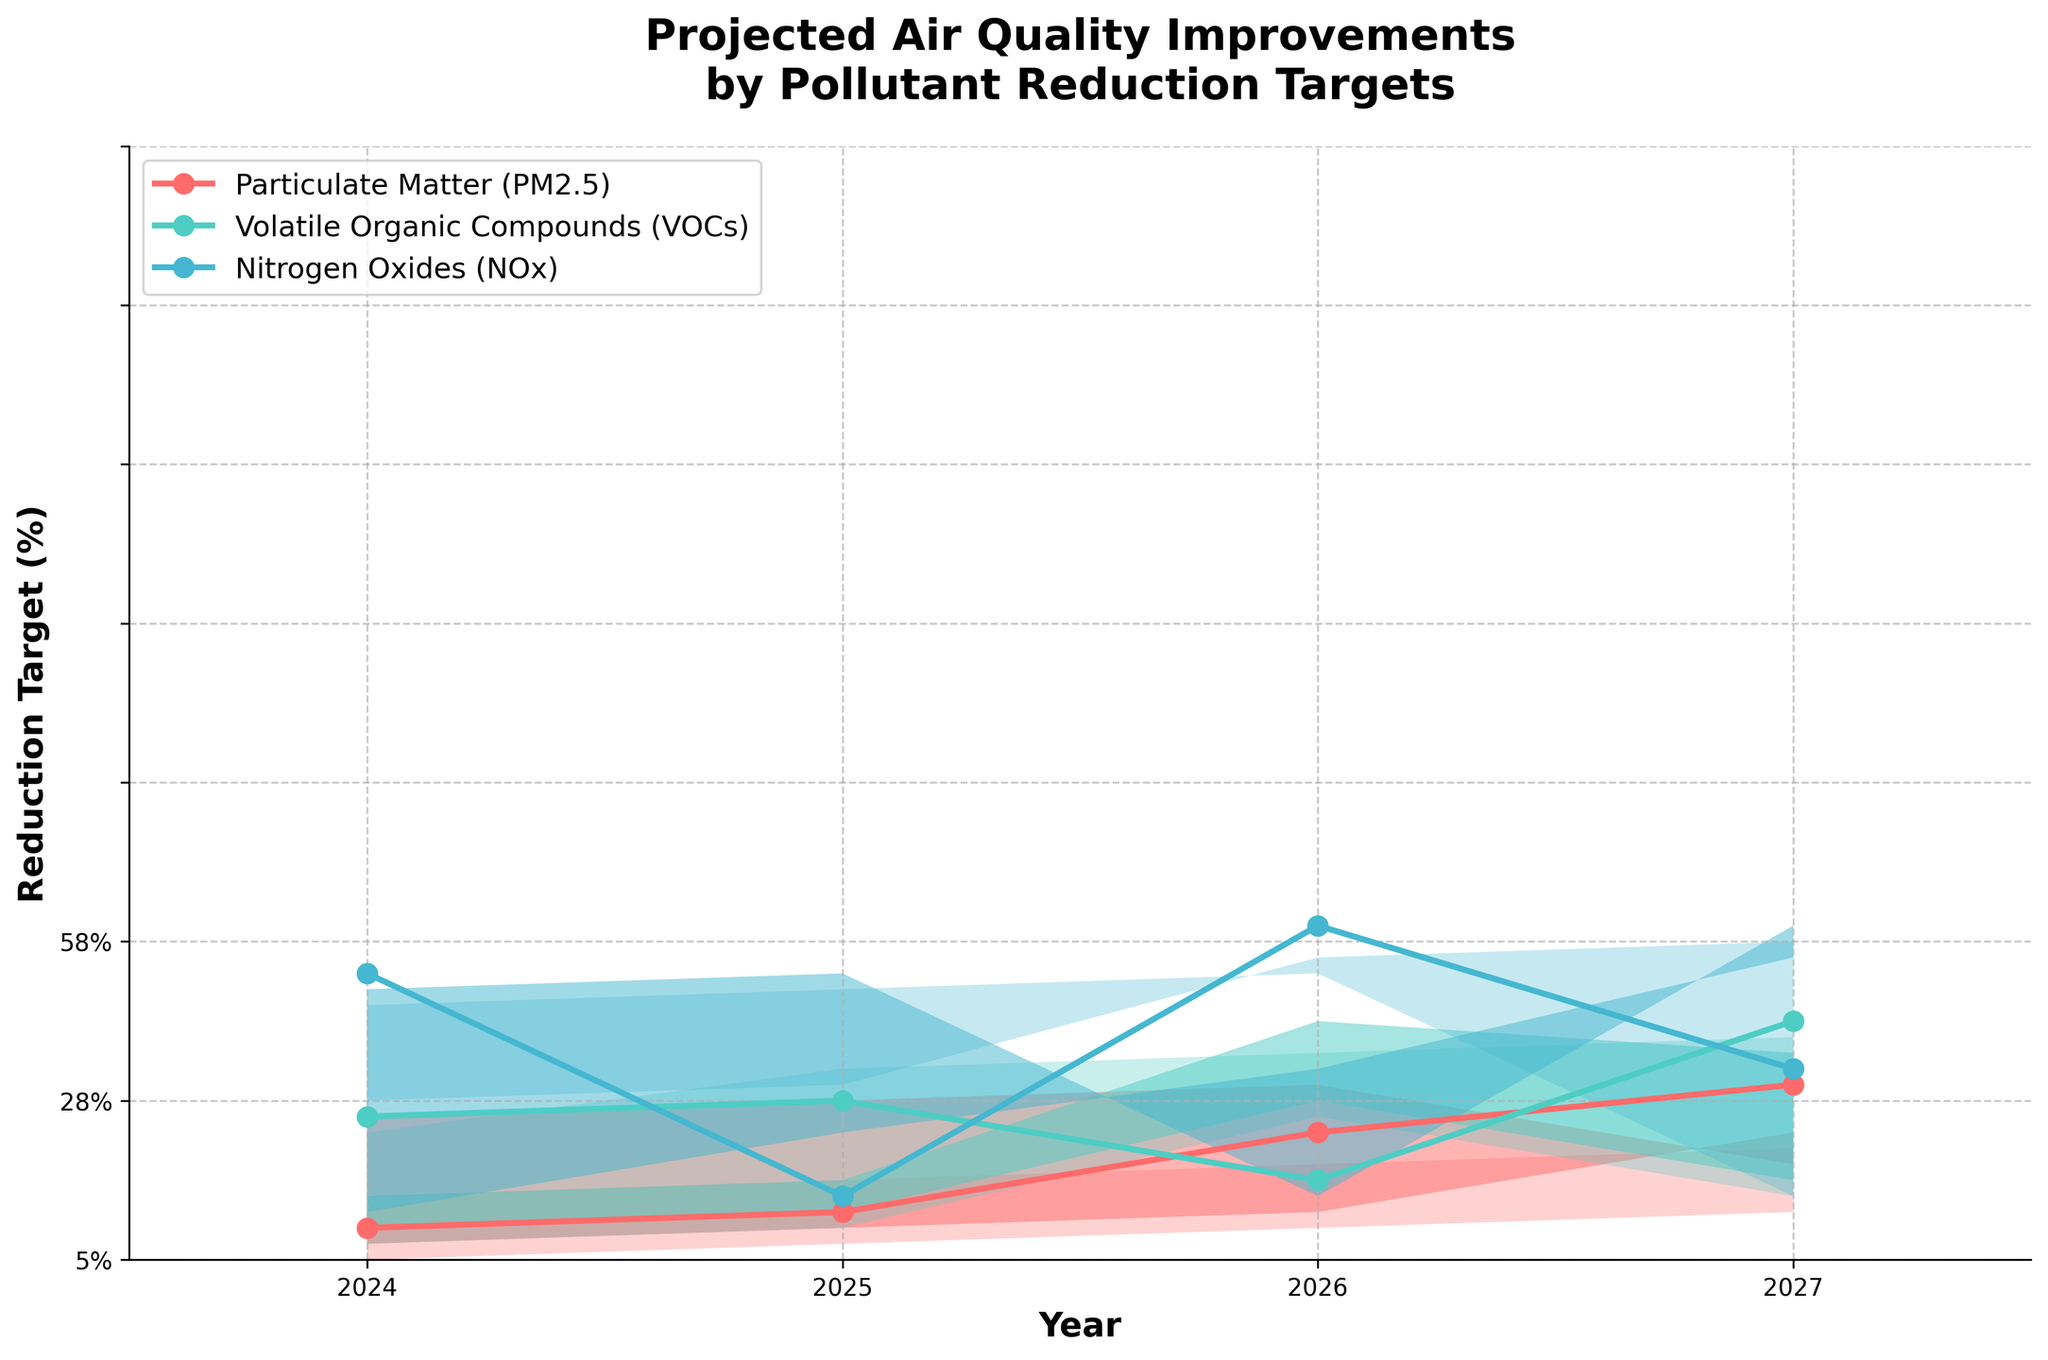How many pollutants are tracked in the figure? The figure displays lines and shaded areas for Particulate Matter (PM2.5), Volatile Organic Compounds (VOCs), and Nitrogen Oxides (NOx). Counting these, we have three pollutants in the figure.
Answer: 3 What is the highest reduction target for Volatile Organic Compounds (VOCs) in 2027? For VOCs in 2027, the high range is noted at 60%. This represents the highest reduction target for VOCs.
Answer: 60% Which pollutant shows the largest increase in the median reduction target from 2024 to 2027? For Particulate Matter (PM2.5), the median goes from 15% (2024) to 38% (2027), increase of 23%. For VOCs, the median goes from 20% (2024) to 42% (2027), increase of 22%. For NOx, the median goes from 18% (2024) to 40% (2027), increase of 22%. PM2.5 shows the largest increase.
Answer: Particulate Matter (PM2.5) What is the range of reduction targets for Nitrogen Oxides (NOx) in 2025? In 2025, the reduction targets for NOx range from a low of 12% to a high of 38%. This creates a range of (38% - 12%) = 26%.
Answer: 26% Which year has the smallest difference between the highest and lowest reduction targets for Particulate Matter (PM2.5)? In 2024, the range is (25% - 5%) = 20%. In 2025, the range is (35% - 10%) = 25%. In 2026, the range is (45% - 15%) = 30%. In 2027, the range is (55% - 22%) = 33%. Hence, 2024 has the smallest difference.
Answer: 2024 Are the reduction target ranges increasing or decreasing over the years for VOCs? The range for VOCs in 2024 is (30% - 10%) = 20%. In 2025, it is (40% - 15%) = 25%. In 2026, it is (50% - 20%) = 30%. In 2027, it is (60% - 25%) = 35%. The ranges are increasing each year.
Answer: Increasing Which pollutant has the highest median reduction target in 2026? By examining the midline values for 2026, we note Particulate Matter (PM2.5) has a median of 30%, VOCs show 35%, and NOx has 32%. Therefore, VOCs have the highest.
Answer: VOCs In which year does the median reduction target for Nitrogen Oxides (NOx) exceed 30% for the first time? Reviewing the values, NOx reaches a median of 32% in 2026. Thus, 2026 is the first year the target exceeds 30%.
Answer: 2026 Is the projected air quality improvement higher for Particulate Matter (PM2.5) or Nitrogen Oxides (NOx) in 2027? For 2027, the high range for PM2.5 is 55%, while the high range for NOx is 58%. Therefore, NOx has a higher projected improvement.
Answer: Nitrogen Oxides (NOx) 